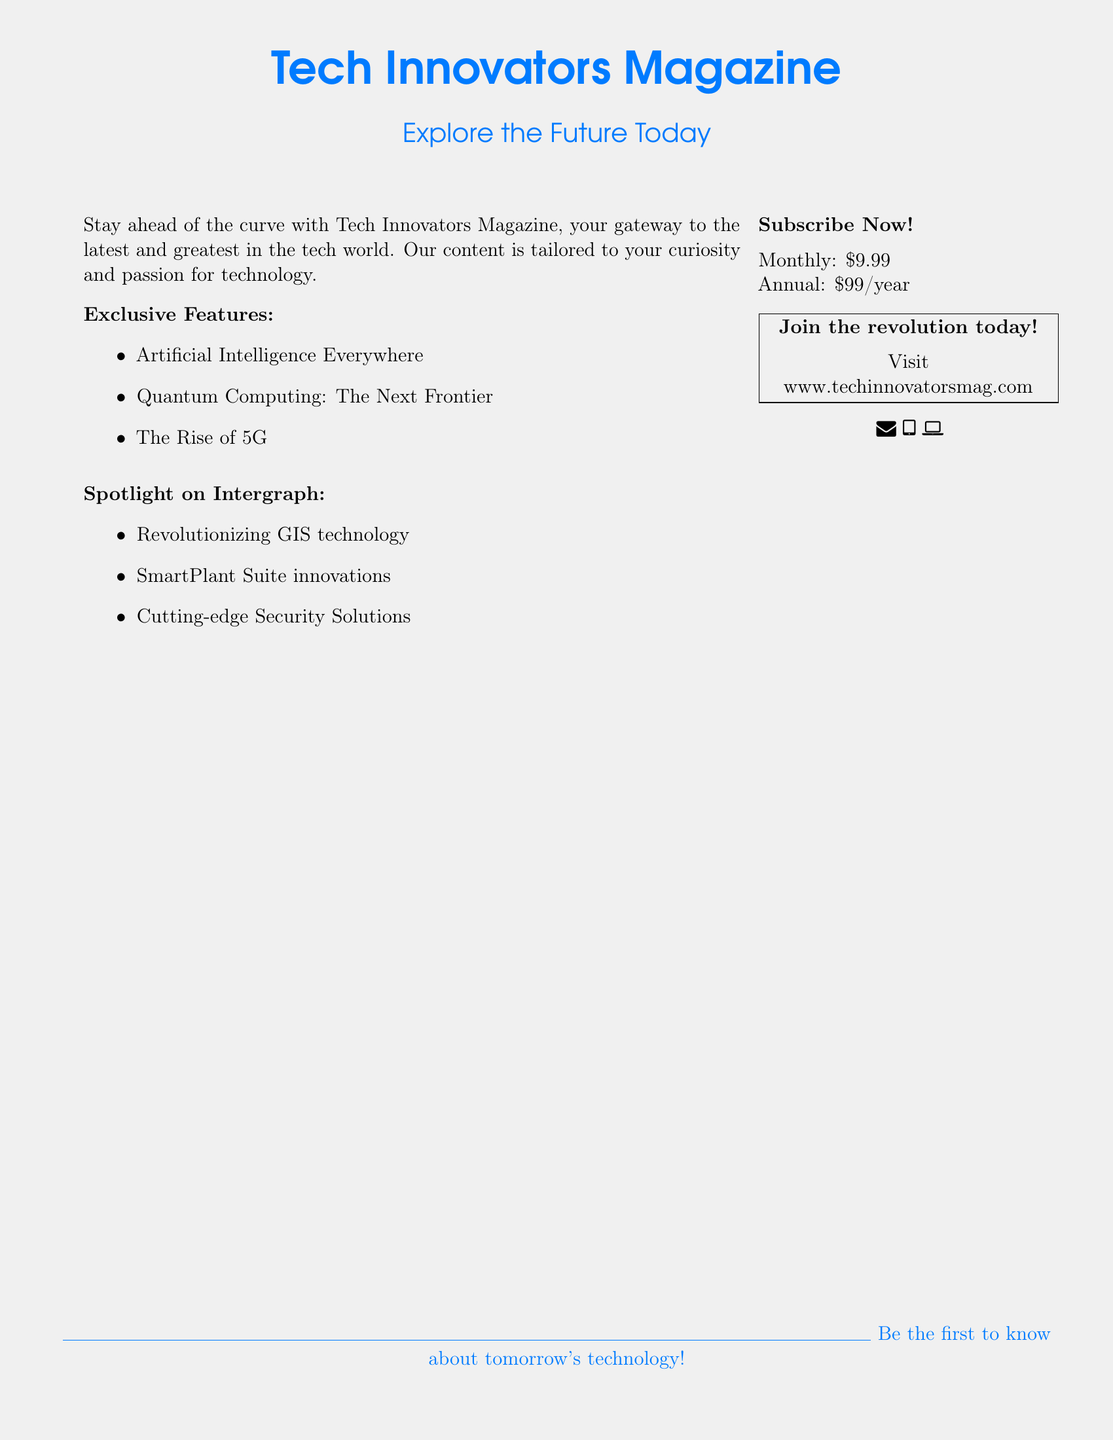What is the name of the magazine? The name of the magazine is prominently stated at the top of the document.
Answer: Tech Innovators Magazine What are the monthly subscription rates? The document lists the pricing for both monthly and annual subscriptions.
Answer: $9.99 What technology is spotlighted alongside Intergraph? The document mentions several featured technologies in a specific section, including the name mentioned with Intergraph.
Answer: GIS technology What is one exclusive feature mentioned in the magazine? The document lists a few exclusive features related to emerging technologies.
Answer: Artificial Intelligence Everywhere How much is the annual subscription? Annual subscription pricing is clearly displayed for potential subscribers.
Answer: $99/year Where can you visit to subscribe? The document provides a website address where readers can subscribe.
Answer: www.techinnovatorsmag.com What color is used for the magazine title? The document highlights the title using a specific color mentioned in its description.
Answer: Tech blue What type of content does Tech Innovators Magazine provide? A brief description in the document outlines the magazine's focus on technological advancements.
Answer: Latest and greatest in the tech world What type of solutions does Intergraph provide? The spotlight section outlines certain types of innovations by Intergraph mentioned in the document.
Answer: Cutting-edge Security Solutions 